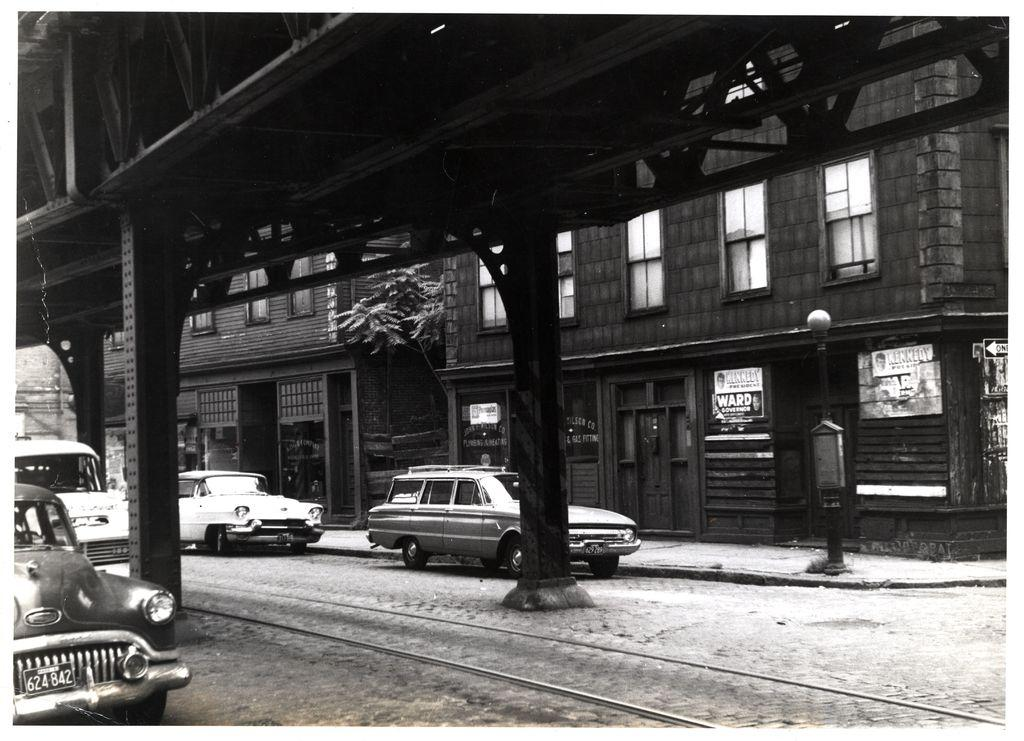What can be seen moving on the road in the image? There are vehicles on the road in the image. What type of structures are visible in the image? There are buildings in the image. What type of natural elements are present in the image? There are trees in the image. What other objects can be seen on the ground in the image? There are other objects on the ground in the image. What is the color scheme of the image? The image is black and white in color. Can you hear the voice of the goose in the image? There is no goose present in the image, so there is no voice to hear. What is the wealth of the people living in the buildings in the image? The image does not provide any information about the wealth of the people living in the buildings. 